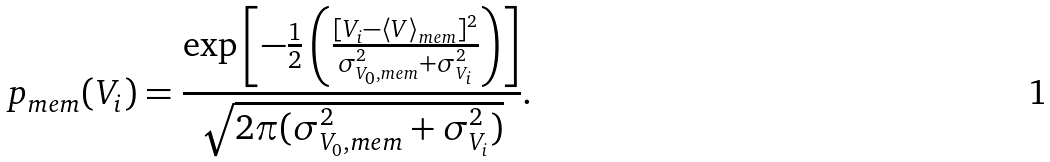Convert formula to latex. <formula><loc_0><loc_0><loc_500><loc_500>p _ { m e m } ( V _ { i } ) = \frac { \exp \left [ - \frac { 1 } { 2 } \left ( \frac { [ V _ { i } - \langle V \rangle _ { m e m } ] ^ { 2 } } { \sigma _ { V _ { 0 } , m e m } ^ { 2 } + \sigma _ { V _ { i } } ^ { 2 } } \right ) \right ] } { \sqrt { 2 \pi ( \sigma _ { V _ { 0 } , m e m } ^ { 2 } + \sigma _ { V _ { i } } ^ { 2 } ) } } .</formula> 